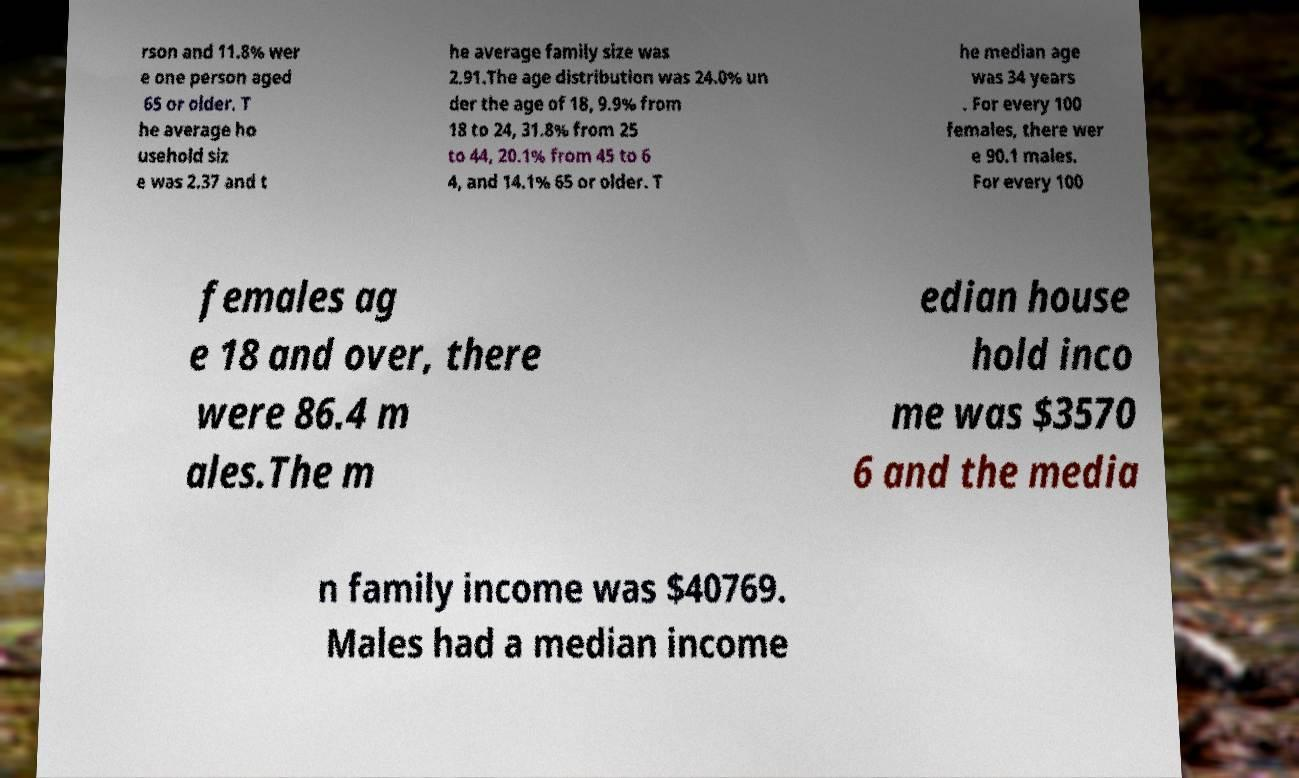What messages or text are displayed in this image? I need them in a readable, typed format. rson and 11.8% wer e one person aged 65 or older. T he average ho usehold siz e was 2.37 and t he average family size was 2.91.The age distribution was 24.0% un der the age of 18, 9.9% from 18 to 24, 31.8% from 25 to 44, 20.1% from 45 to 6 4, and 14.1% 65 or older. T he median age was 34 years . For every 100 females, there wer e 90.1 males. For every 100 females ag e 18 and over, there were 86.4 m ales.The m edian house hold inco me was $3570 6 and the media n family income was $40769. Males had a median income 